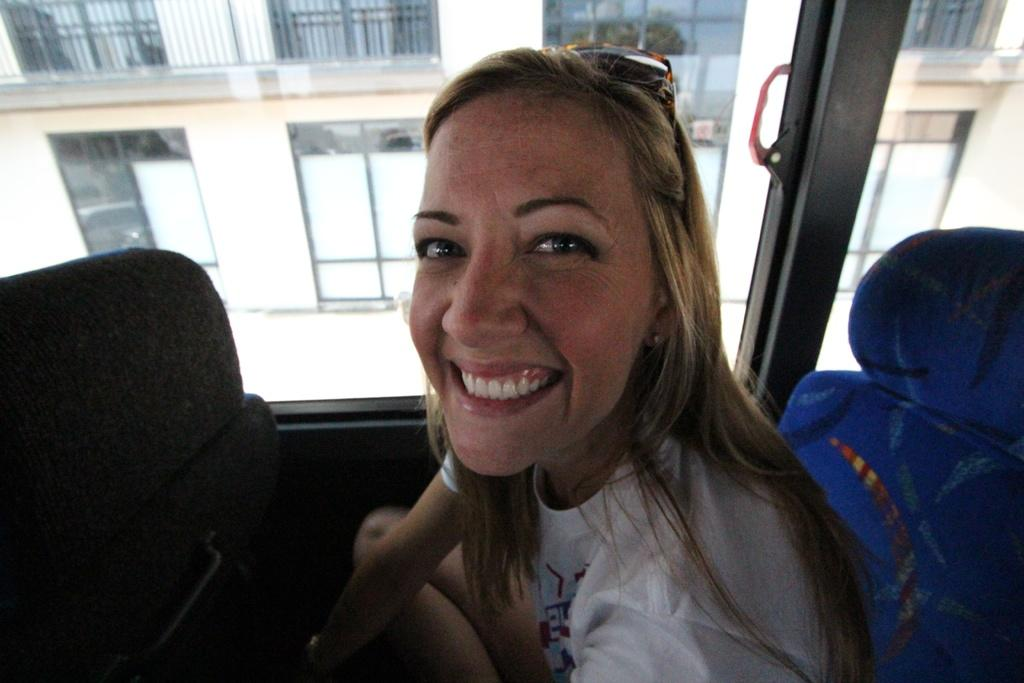Who is in the picture? There is a woman in the picture. What is the woman wearing? The woman is wearing a white T-shirt. What is the woman doing in the picture? The woman is sitting and smiling. What object is beside the woman? There is a glass beside the woman. What can be seen in the background of the picture? There is a building in the background of the picture. What type of toothpaste is the woman discussing in the picture? There is no toothpaste or discussion present in the image. How does the woman's cough affect the people around her in the picture? There is no cough or people around her present in the image. 